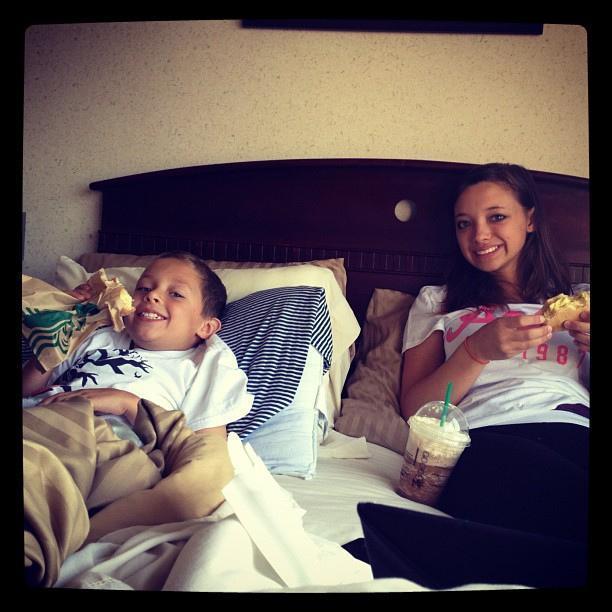How many people are there?
Give a very brief answer. 2. How many birds are in this photo?
Give a very brief answer. 0. 